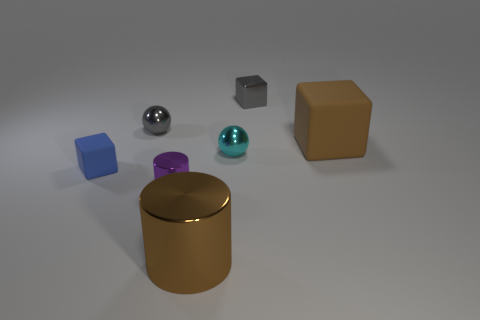How many other objects are there of the same shape as the tiny purple shiny thing?
Keep it short and to the point. 1. Is there a small blue metal cube?
Offer a terse response. No. How many things are cyan cylinders or small shiny spheres on the left side of the large brown cylinder?
Offer a very short reply. 1. There is a matte object that is behind the blue cube; is its size the same as the tiny metallic cylinder?
Offer a very short reply. No. What number of other things are there of the same size as the blue matte cube?
Offer a terse response. 4. What is the color of the tiny rubber block?
Make the answer very short. Blue. What is the material of the brown thing behind the small purple thing?
Give a very brief answer. Rubber. Are there an equal number of tiny objects on the right side of the tiny blue rubber block and large red metal spheres?
Offer a terse response. No. Do the purple thing and the large shiny object have the same shape?
Make the answer very short. Yes. Are there any other things of the same color as the small metallic cube?
Provide a short and direct response. Yes. 